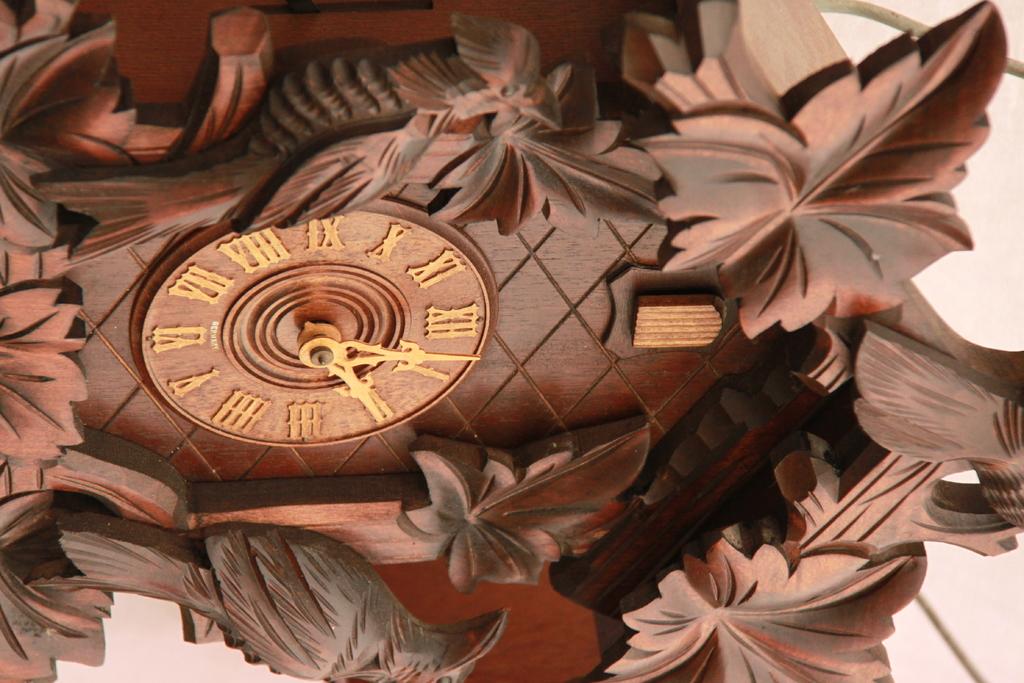What time is on the clock?
Your answer should be very brief. 2:03. What is the higest number on the clock?
Offer a terse response. 12. 